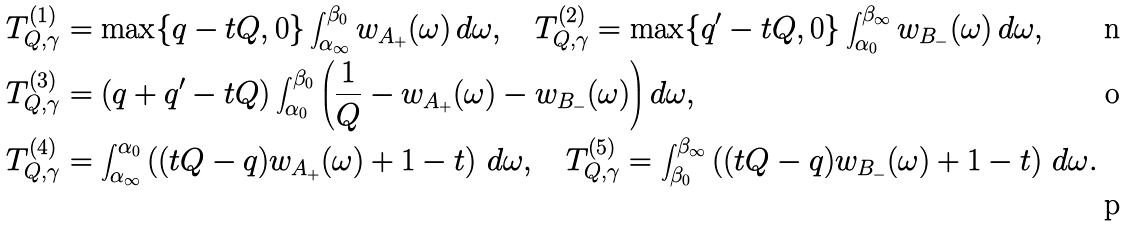Convert formula to latex. <formula><loc_0><loc_0><loc_500><loc_500>T ^ { ( 1 ) } _ { Q , \gamma } & = \max \{ q - t Q , 0 \} \int _ { \alpha _ { \infty } } ^ { \beta _ { 0 } } w _ { A _ { + } } ( \omega ) \, d \omega , \quad T ^ { ( 2 ) } _ { Q , \gamma } = \max \{ q ^ { \prime } - t Q , 0 \} \int _ { \alpha _ { 0 } } ^ { \beta _ { \infty } } w _ { B _ { - } } ( \omega ) \, d \omega , \\ T ^ { ( 3 ) } _ { Q , \gamma } & = ( q + q ^ { \prime } - t Q ) \int _ { \alpha _ { 0 } } ^ { \beta _ { 0 } } \left ( \frac { 1 } { Q } - w _ { A _ { + } } ( \omega ) - w _ { B _ { - } } ( \omega ) \right ) d \omega , \\ T ^ { ( 4 ) } _ { Q , \gamma } & = \int _ { \alpha _ { \infty } } ^ { \alpha _ { 0 } } \left ( ( t Q - q ) w _ { A _ { + } } ( \omega ) + 1 - t \right ) \, d \omega , \quad T ^ { ( 5 ) } _ { Q , \gamma } = \int _ { \beta _ { 0 } } ^ { \beta _ { \infty } } \left ( ( t Q - q ) w _ { B _ { - } } ( \omega ) + 1 - t \right ) \, d \omega .</formula> 